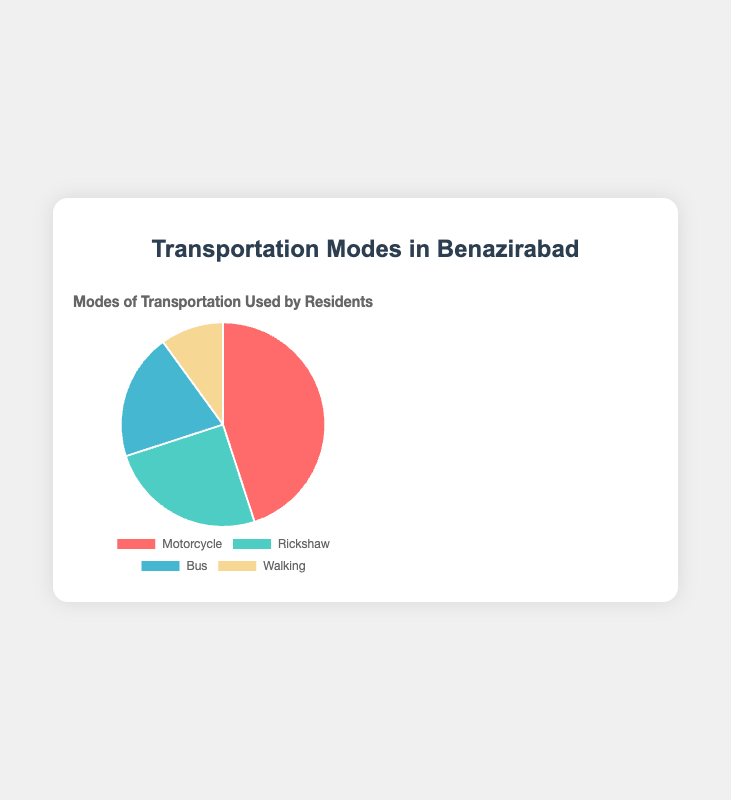Which transportation mode is used by the highest percentage of residents? The slice representing "Motorcycle" appears the largest in the pie chart with a 45% share.
Answer: Motorcycle What percentage of residents use either Motorcycle or Rickshaw for transportation? Adding the percentages of those who use Motorcycle and Rickshaw: 45% + 25% = 70%.
Answer: 70% Which mode of transportation is least used by residents of Benazirabad? The smallest slice in the pie chart represents "Walking" with a 10% share.
Answer: Walking How much more popular is using a motorcycle compared to walking? Subtract the percentage of Walking from Motorcycle: 45% - 10% = 35%.
Answer: 35% Is using a Bus more popular than walking? The percentage for Bus is 20% while for Walking it's 10%. Since 20% is greater than 10%, using a Bus is more popular.
Answer: Yes What is the combined percentage of residents who use either Bus or Rickshaw? Adding the percentages of those who use Bus and Rickshaw: 20% + 25% = 45%.
Answer: 45% What is the difference in percentage between those who use Rickshaw and those who use Bus? Subtract the percentage of Bus from Rickshaw: 25% - 20% = 5%.
Answer: 5% Describe the color of the slice representing the most used mode of transportation. The slice representing Motorcycle, which is the most used mode of transportation, is red in color.
Answer: Red If you were to add the percentages of the three least used transport modes, what would be the total? Adding the percentages of Rickshaw, Bus, and Walking: 25% + 20% + 10% = 55%.
Answer: 55% Which transportation mode is represented by the blue color in the chart? The blue-colored slice represents the "Bus" mode of transportation.
Answer: Bus 